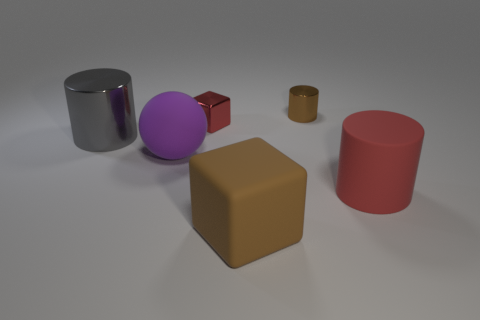How big is the metal cylinder on the left side of the large object that is in front of the red cylinder?
Your response must be concise. Large. Is the shape of the brown object that is behind the gray thing the same as  the big red thing?
Your answer should be compact. Yes. There is a big brown object that is the same shape as the tiny red metal thing; what material is it?
Ensure brevity in your answer.  Rubber. What number of objects are shiny things on the right side of the tiny cube or brown things that are behind the large red rubber thing?
Provide a short and direct response. 1. Does the matte sphere have the same color as the cube that is in front of the large red matte object?
Ensure brevity in your answer.  No. The gray thing that is the same material as the small cube is what shape?
Make the answer very short. Cylinder. What number of tiny purple metal cylinders are there?
Your answer should be compact. 0. What number of objects are red things to the right of the red cube or matte things?
Keep it short and to the point. 3. Does the shiny cylinder that is on the right side of the purple matte thing have the same color as the big rubber cylinder?
Offer a terse response. No. What number of other objects are the same color as the rubber sphere?
Keep it short and to the point. 0. 